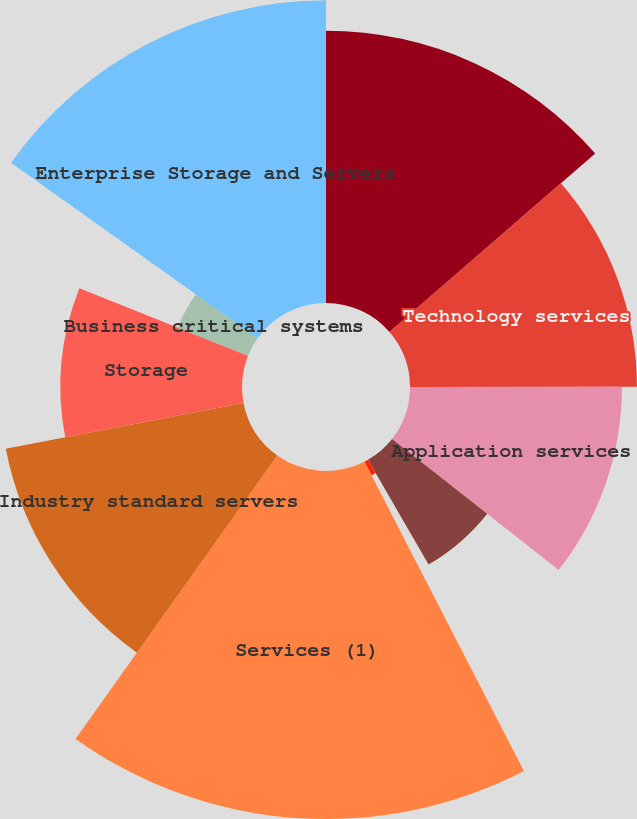Convert chart to OTSL. <chart><loc_0><loc_0><loc_500><loc_500><pie_chart><fcel>Infrastructure technology<fcel>Technology services<fcel>Application services<fcel>Business process outsourcing<fcel>Other<fcel>Services (1)<fcel>Industry standard servers<fcel>Storage<fcel>Business critical systems<fcel>Enterprise Storage and Servers<nl><fcel>13.63%<fcel>11.36%<fcel>10.61%<fcel>6.06%<fcel>0.76%<fcel>17.42%<fcel>12.12%<fcel>9.09%<fcel>3.79%<fcel>15.15%<nl></chart> 